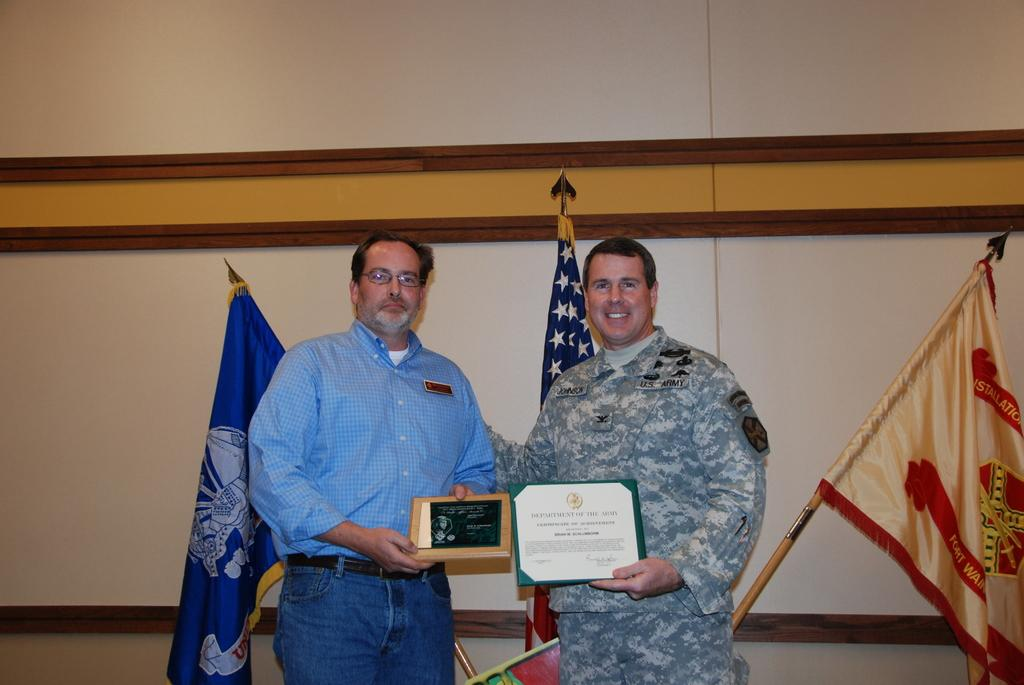How many people are present in the image? There are two people in the image. What are the people holding in their hands? The people are holding memorandums. What can be seen in the background of the image? There are flags visible in the image, and there is a wall behind the flags. What type of dress is the parent wearing in the image? There is no parent or dress present in the image. What kind of feast is being prepared in the image? There is no feast or preparation visible in the image. 